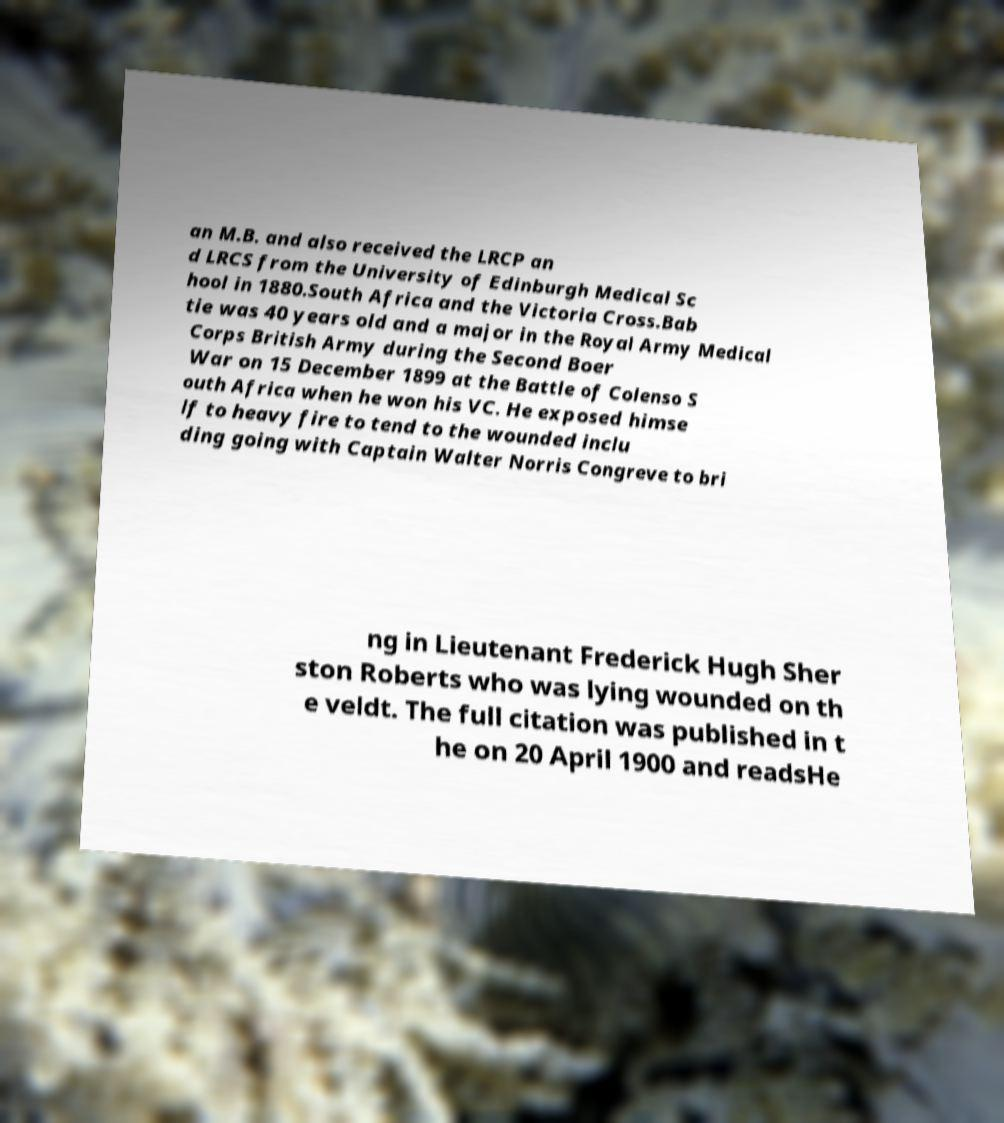For documentation purposes, I need the text within this image transcribed. Could you provide that? an M.B. and also received the LRCP an d LRCS from the University of Edinburgh Medical Sc hool in 1880.South Africa and the Victoria Cross.Bab tie was 40 years old and a major in the Royal Army Medical Corps British Army during the Second Boer War on 15 December 1899 at the Battle of Colenso S outh Africa when he won his VC. He exposed himse lf to heavy fire to tend to the wounded inclu ding going with Captain Walter Norris Congreve to bri ng in Lieutenant Frederick Hugh Sher ston Roberts who was lying wounded on th e veldt. The full citation was published in t he on 20 April 1900 and readsHe 